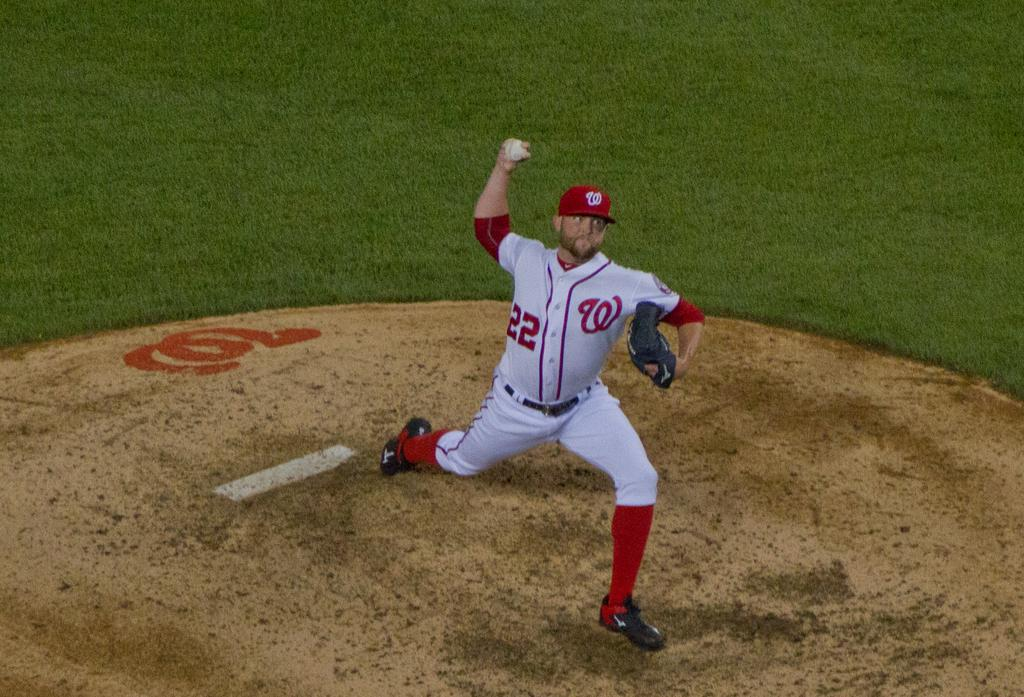What is present in the image? There is a person in the image. What is the person holding in his hand? The person is holding a ball in his hand. What type of surface is visible on the ground? There is grass visible on the ground. Where is the cobweb located in the image? There is no cobweb present in the image. How many hands does the person have in the image? The person in the image has two hands, as is typical for humans. 